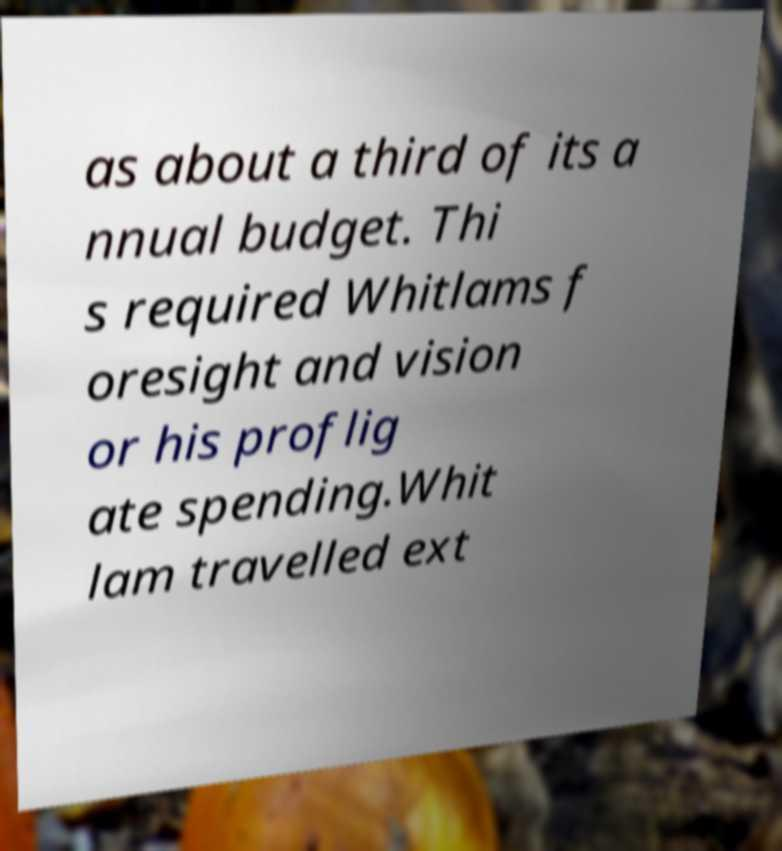There's text embedded in this image that I need extracted. Can you transcribe it verbatim? as about a third of its a nnual budget. Thi s required Whitlams f oresight and vision or his proflig ate spending.Whit lam travelled ext 